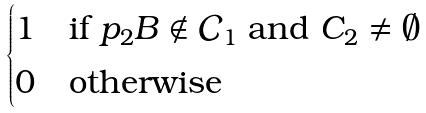<formula> <loc_0><loc_0><loc_500><loc_500>\begin{cases} 1 & \text {if } p _ { 2 } B \not \in \mathcal { C } _ { 1 } \text { and } C _ { 2 } \neq \emptyset \\ 0 & \text {otherwise} \end{cases}</formula> 